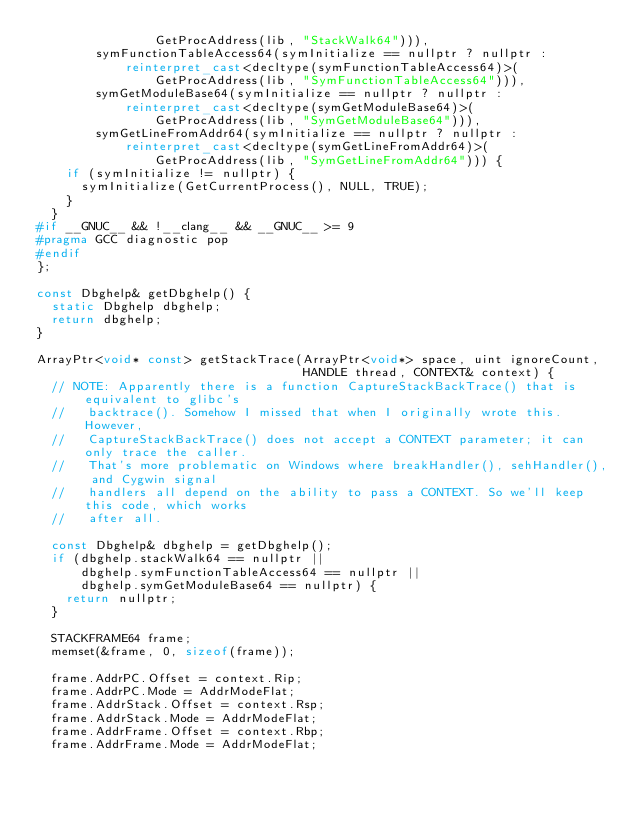<code> <loc_0><loc_0><loc_500><loc_500><_C++_>                GetProcAddress(lib, "StackWalk64"))),
        symFunctionTableAccess64(symInitialize == nullptr ? nullptr :
            reinterpret_cast<decltype(symFunctionTableAccess64)>(
                GetProcAddress(lib, "SymFunctionTableAccess64"))),
        symGetModuleBase64(symInitialize == nullptr ? nullptr :
            reinterpret_cast<decltype(symGetModuleBase64)>(
                GetProcAddress(lib, "SymGetModuleBase64"))),
        symGetLineFromAddr64(symInitialize == nullptr ? nullptr :
            reinterpret_cast<decltype(symGetLineFromAddr64)>(
                GetProcAddress(lib, "SymGetLineFromAddr64"))) {
    if (symInitialize != nullptr) {
      symInitialize(GetCurrentProcess(), NULL, TRUE);
    }
  }
#if __GNUC__ && !__clang__ && __GNUC__ >= 9
#pragma GCC diagnostic pop
#endif
};

const Dbghelp& getDbghelp() {
  static Dbghelp dbghelp;
  return dbghelp;
}

ArrayPtr<void* const> getStackTrace(ArrayPtr<void*> space, uint ignoreCount,
                                    HANDLE thread, CONTEXT& context) {
  // NOTE: Apparently there is a function CaptureStackBackTrace() that is equivalent to glibc's
  //   backtrace(). Somehow I missed that when I originally wrote this. However,
  //   CaptureStackBackTrace() does not accept a CONTEXT parameter; it can only trace the caller.
  //   That's more problematic on Windows where breakHandler(), sehHandler(), and Cygwin signal
  //   handlers all depend on the ability to pass a CONTEXT. So we'll keep this code, which works
  //   after all.

  const Dbghelp& dbghelp = getDbghelp();
  if (dbghelp.stackWalk64 == nullptr ||
      dbghelp.symFunctionTableAccess64 == nullptr ||
      dbghelp.symGetModuleBase64 == nullptr) {
    return nullptr;
  }

  STACKFRAME64 frame;
  memset(&frame, 0, sizeof(frame));

  frame.AddrPC.Offset = context.Rip;
  frame.AddrPC.Mode = AddrModeFlat;
  frame.AddrStack.Offset = context.Rsp;
  frame.AddrStack.Mode = AddrModeFlat;
  frame.AddrFrame.Offset = context.Rbp;
  frame.AddrFrame.Mode = AddrModeFlat;
</code> 